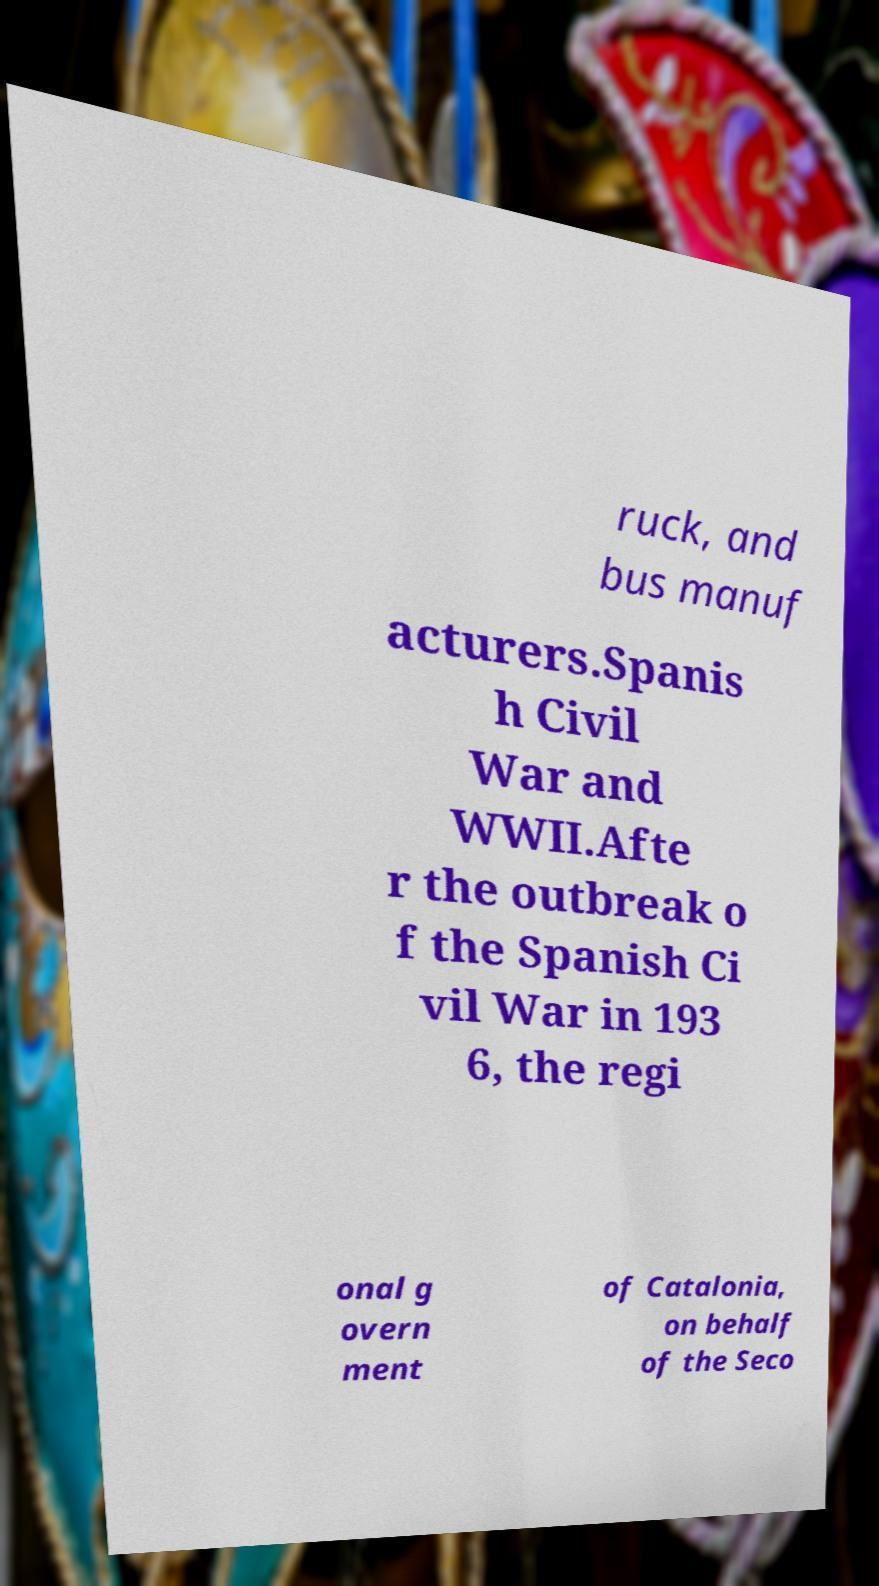Please read and relay the text visible in this image. What does it say? ruck, and bus manuf acturers.Spanis h Civil War and WWII.Afte r the outbreak o f the Spanish Ci vil War in 193 6, the regi onal g overn ment of Catalonia, on behalf of the Seco 